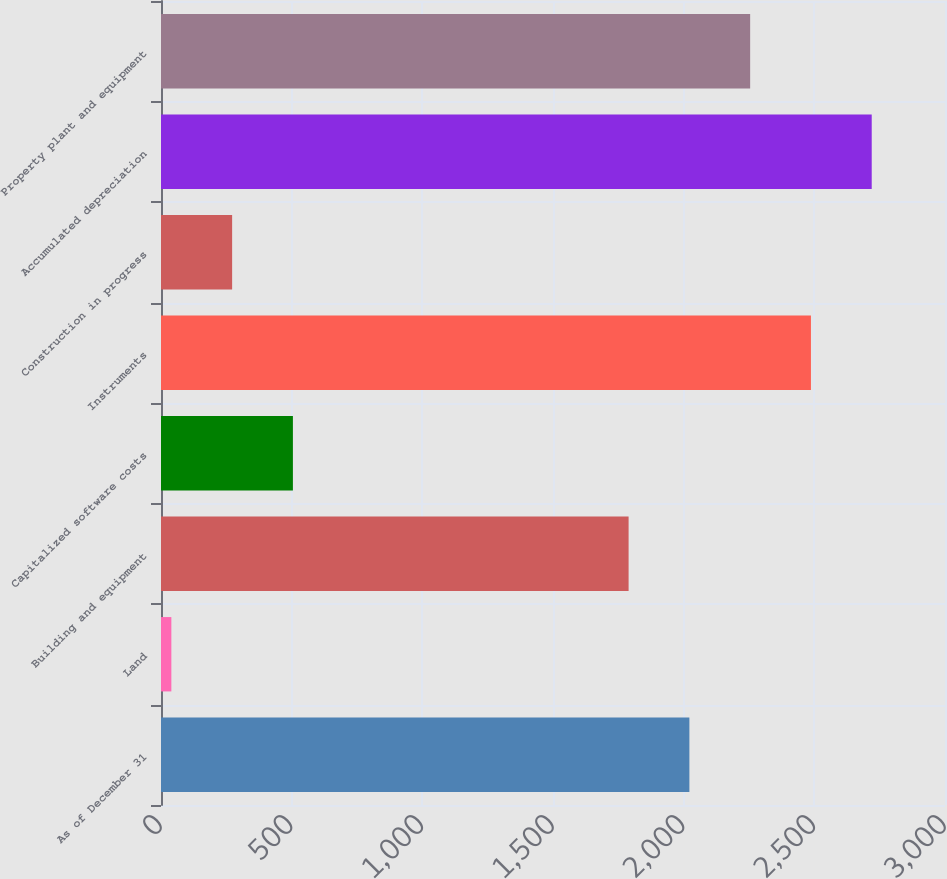<chart> <loc_0><loc_0><loc_500><loc_500><bar_chart><fcel>As of December 31<fcel>Land<fcel>Building and equipment<fcel>Capitalized software costs<fcel>Instruments<fcel>Construction in progress<fcel>Accumulated depreciation<fcel>Property plant and equipment<nl><fcel>2021.87<fcel>39.6<fcel>1789.3<fcel>504.74<fcel>2487.01<fcel>272.17<fcel>2719.58<fcel>2254.44<nl></chart> 